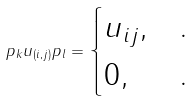Convert formula to latex. <formula><loc_0><loc_0><loc_500><loc_500>p _ { k } u _ { ( i , j ) } p _ { l } = \begin{cases} u _ { i j } , & . \\ 0 , & . \end{cases}</formula> 